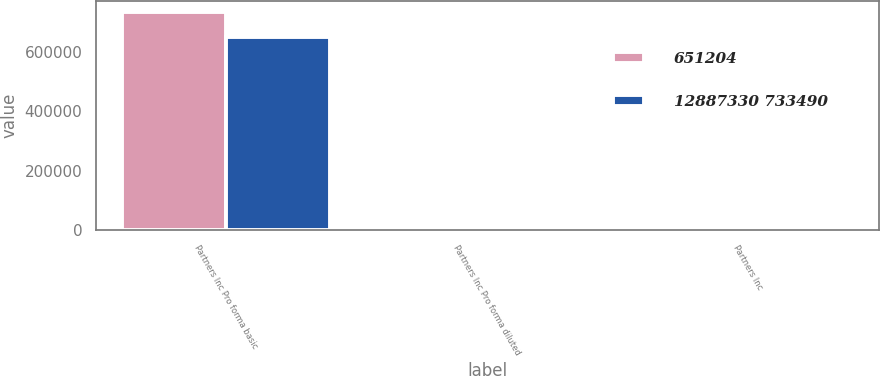<chart> <loc_0><loc_0><loc_500><loc_500><stacked_bar_chart><ecel><fcel>Partners Inc Pro forma basic<fcel>Partners Inc Pro forma diluted<fcel>Partners Inc<nl><fcel>651204<fcel>733490<fcel>3.45<fcel>3.38<nl><fcel>12887330 733490<fcel>651204<fcel>3.1<fcel>3.03<nl></chart> 